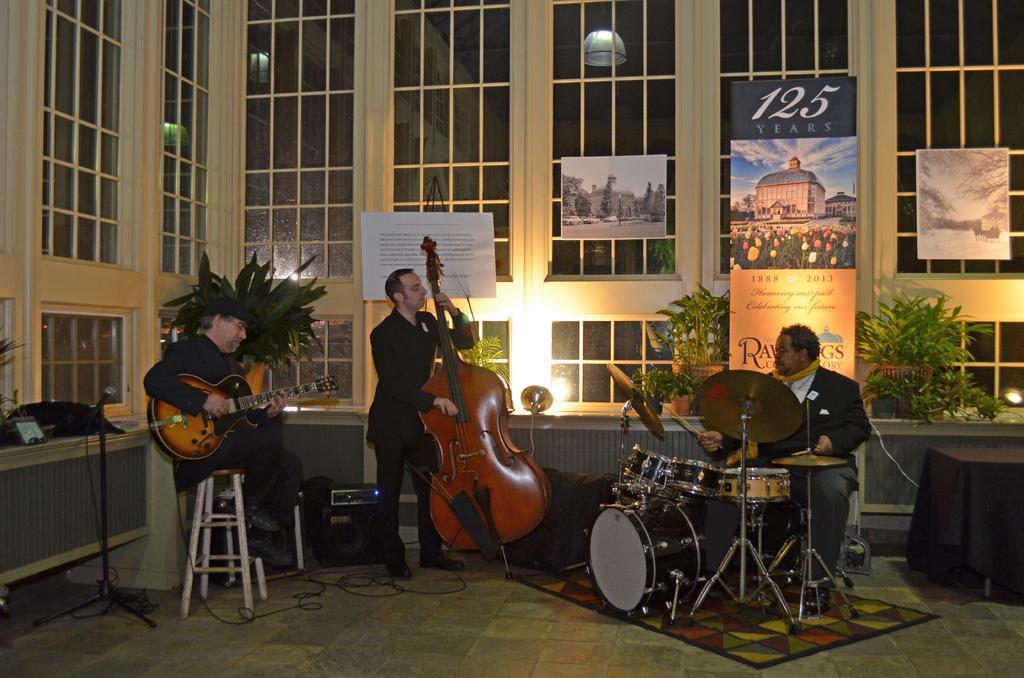How would you summarize this image in a sentence or two? In this image in the middle there is a man he is playing violin he wears suit, trouser and shoes. on the right there is a man he is playing drums. On the left there is a man he is playing guitar. In the background there are mice, window, poster plant and light. 